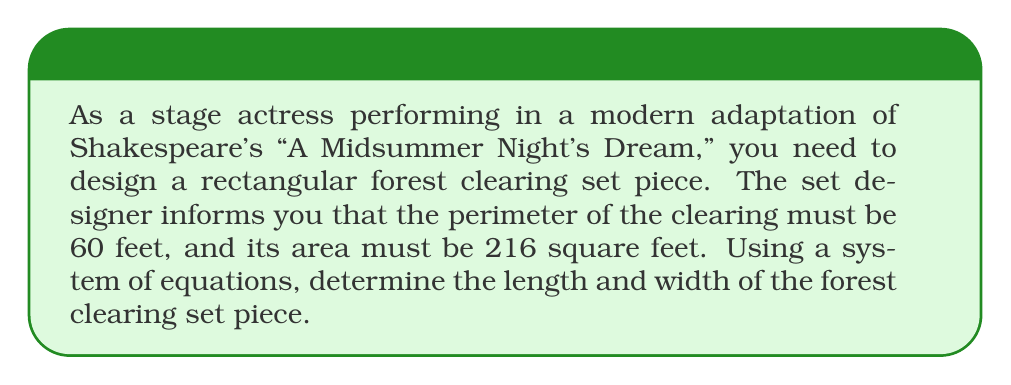What is the answer to this math problem? Let's approach this step-by-step using a system of equations:

1) Let $l$ be the length and $w$ be the width of the rectangular clearing.

2) Given the perimeter is 60 feet, we can write our first equation:
   $$2l + 2w = 60$$

3) The area is 216 square feet, giving us our second equation:
   $$lw = 216$$

4) From the perimeter equation, we can express $l$ in terms of $w$:
   $$2l + 2w = 60$$
   $$2l = 60 - 2w$$
   $$l = 30 - w$$

5) Substitute this into the area equation:
   $$lw = 216$$
   $$(30 - w)w = 216$$

6) Expand the equation:
   $$30w - w^2 = 216$$

7) Rearrange to standard quadratic form:
   $$w^2 - 30w + 216 = 0$$

8) Solve using the quadratic formula: $w = \frac{-b \pm \sqrt{b^2 - 4ac}}{2a}$
   $$w = \frac{30 \pm \sqrt{900 - 864}}{2} = \frac{30 \pm \sqrt{36}}{2} = \frac{30 \pm 6}{2}$$

9) This gives us two solutions: $w = 18$ or $w = 12$

10) Since $l = 30 - w$, the corresponding lengths are $l = 12$ or $l = 18$

11) Both solutions satisfy our original equations, but they're the same rectangle with length and width swapped.
Answer: Length = 18 feet, Width = 12 feet 